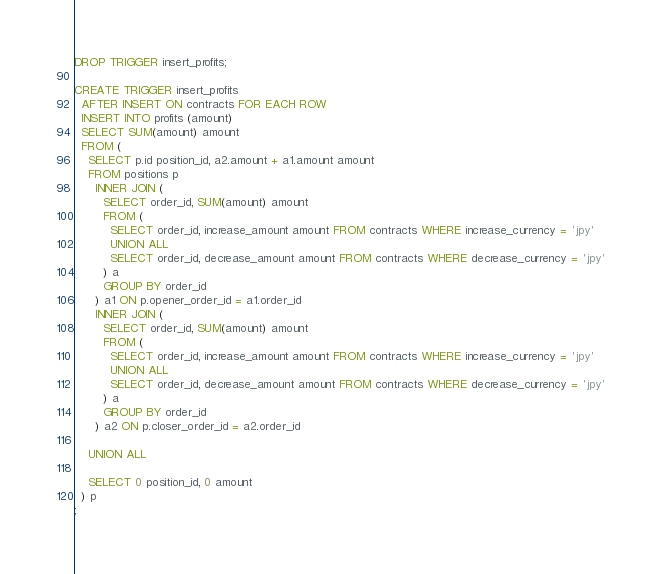Convert code to text. <code><loc_0><loc_0><loc_500><loc_500><_SQL_>DROP TRIGGER insert_profits;

CREATE TRIGGER insert_profits
  AFTER INSERT ON contracts FOR EACH ROW
  INSERT INTO profits (amount)
  SELECT SUM(amount) amount
  FROM (
    SELECT p.id position_id, a2.amount + a1.amount amount
    FROM positions p
      INNER JOIN (
        SELECT order_id, SUM(amount) amount
        FROM (
          SELECT order_id, increase_amount amount FROM contracts WHERE increase_currency = 'jpy'
          UNION ALL
          SELECT order_id, decrease_amount amount FROM contracts WHERE decrease_currency = 'jpy'
        ) a
        GROUP BY order_id
      ) a1 ON p.opener_order_id = a1.order_id
      INNER JOIN (
        SELECT order_id, SUM(amount) amount
        FROM (
          SELECT order_id, increase_amount amount FROM contracts WHERE increase_currency = 'jpy'
          UNION ALL
          SELECT order_id, decrease_amount amount FROM contracts WHERE decrease_currency = 'jpy'
        ) a
        GROUP BY order_id
      ) a2 ON p.closer_order_id = a2.order_id

    UNION ALL
    
    SELECT 0 position_id, 0 amount
  ) p
;</code> 